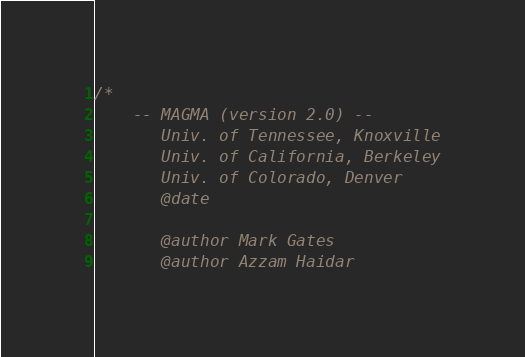Convert code to text. <code><loc_0><loc_0><loc_500><loc_500><_Cuda_>/*
    -- MAGMA (version 2.0) --
       Univ. of Tennessee, Knoxville
       Univ. of California, Berkeley
       Univ. of Colorado, Denver
       @date

       @author Mark Gates
       @author Azzam Haidar
</code> 